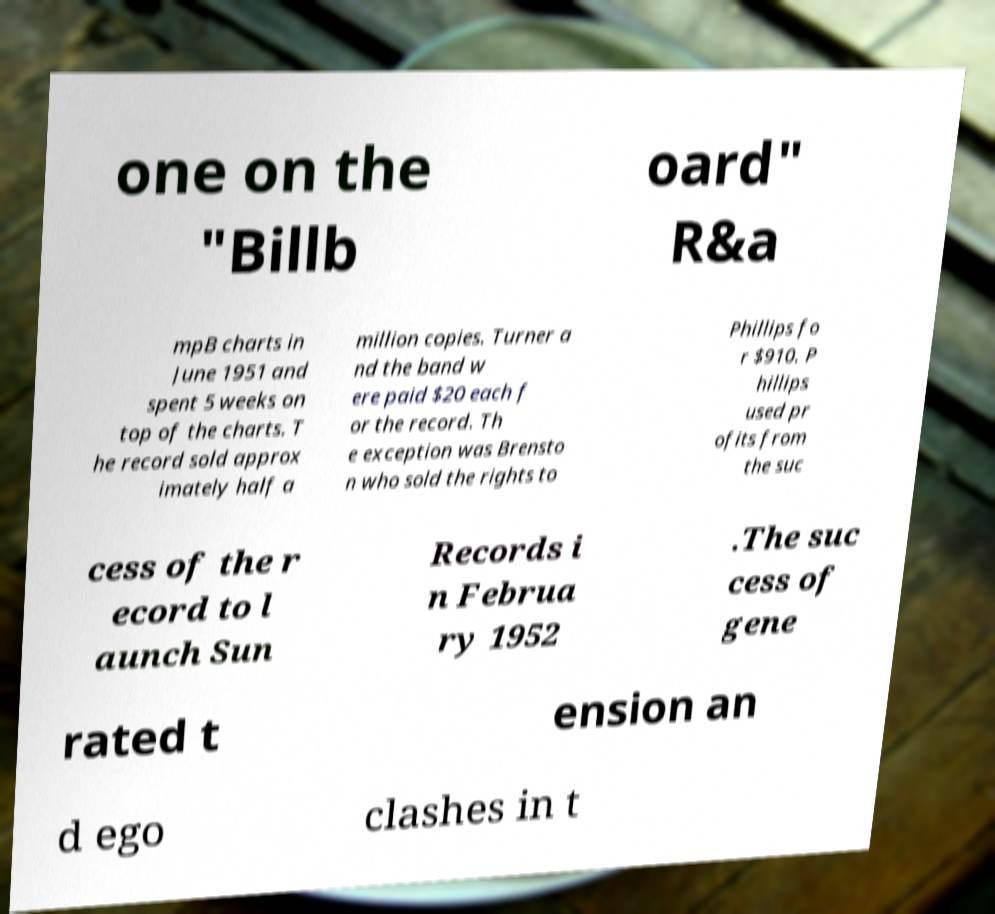There's text embedded in this image that I need extracted. Can you transcribe it verbatim? one on the "Billb oard" R&a mpB charts in June 1951 and spent 5 weeks on top of the charts. T he record sold approx imately half a million copies. Turner a nd the band w ere paid $20 each f or the record. Th e exception was Brensto n who sold the rights to Phillips fo r $910. P hillips used pr ofits from the suc cess of the r ecord to l aunch Sun Records i n Februa ry 1952 .The suc cess of gene rated t ension an d ego clashes in t 